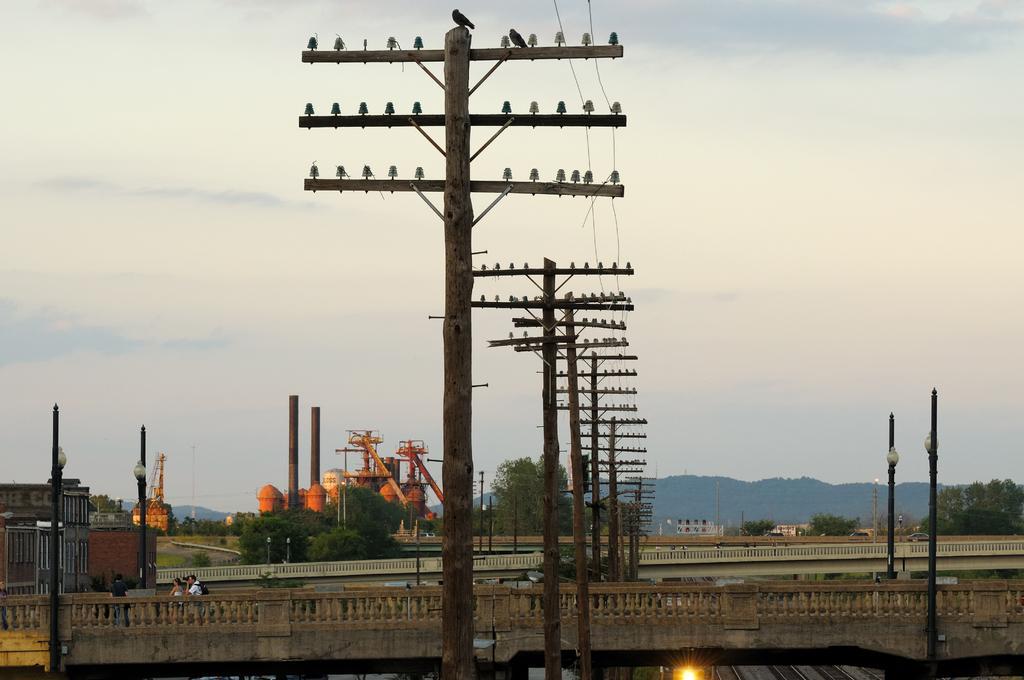How would you summarize this image in a sentence or two? Here we can see poles, trees, few persons, and a light. In the background we can see sky. 